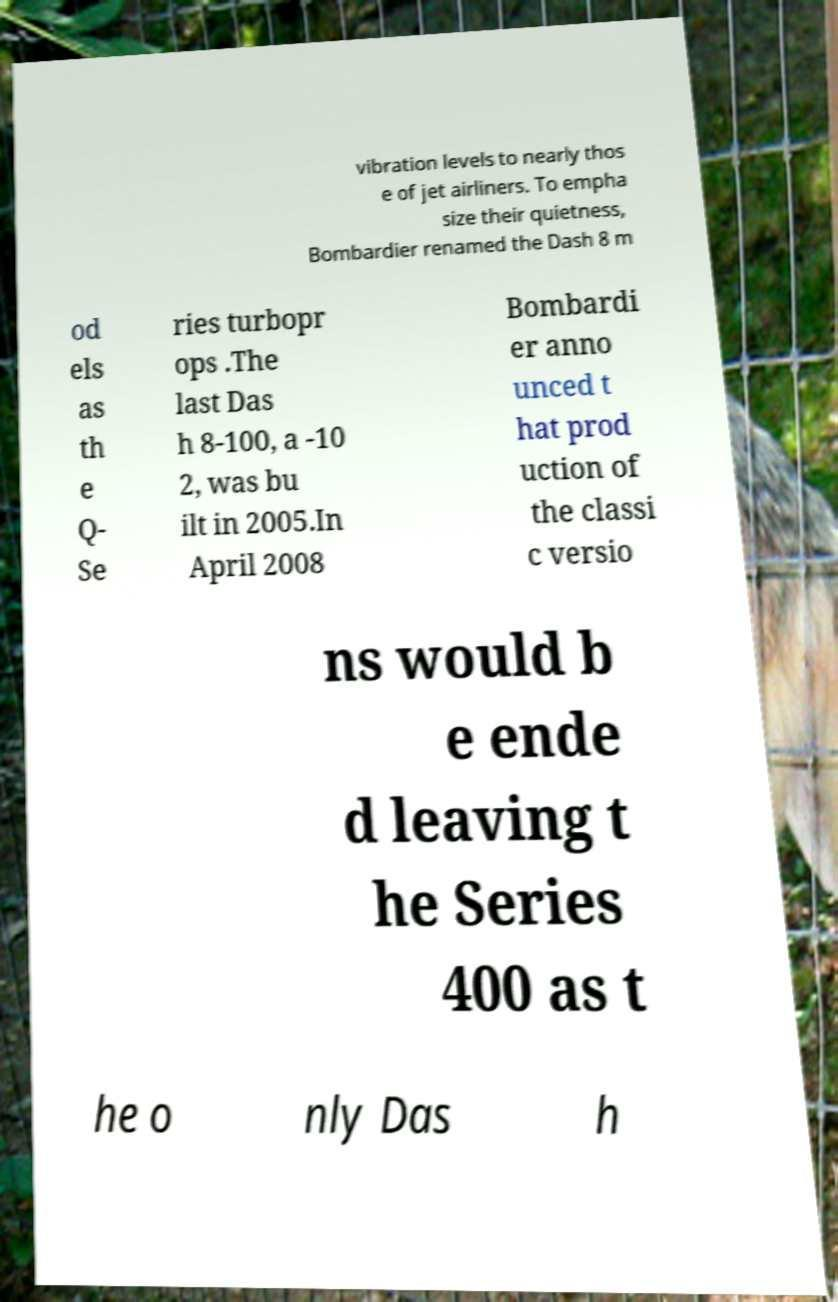Can you read and provide the text displayed in the image?This photo seems to have some interesting text. Can you extract and type it out for me? vibration levels to nearly thos e of jet airliners. To empha size their quietness, Bombardier renamed the Dash 8 m od els as th e Q- Se ries turbopr ops .The last Das h 8-100, a -10 2, was bu ilt in 2005.In April 2008 Bombardi er anno unced t hat prod uction of the classi c versio ns would b e ende d leaving t he Series 400 as t he o nly Das h 